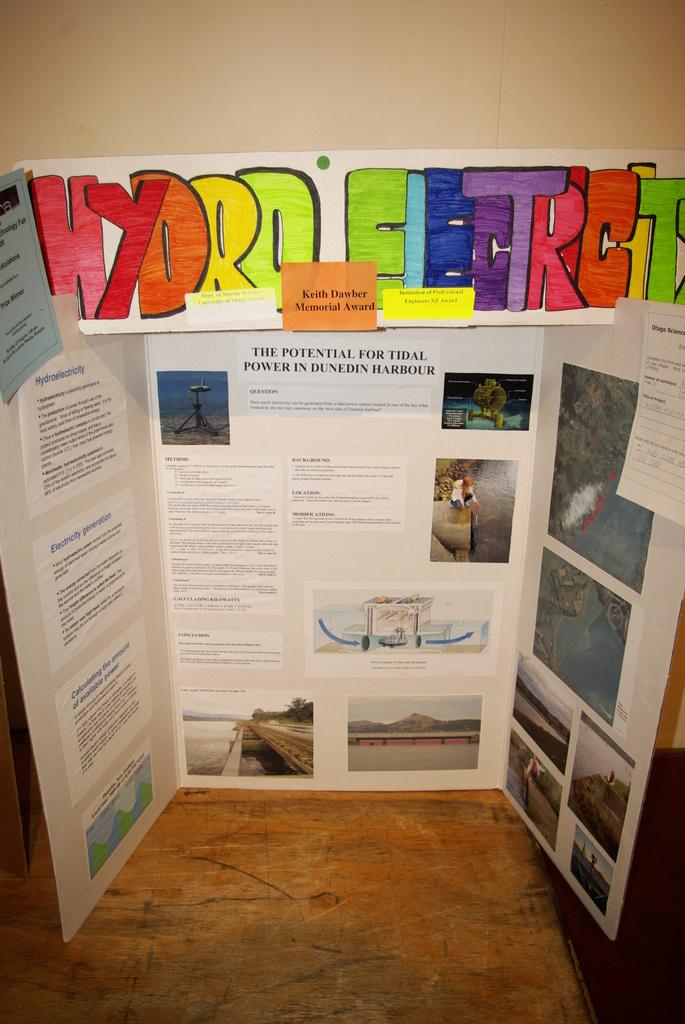<image>
Share a concise interpretation of the image provided. A science fair project backboard on hydro electric 